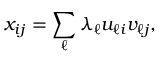Convert formula to latex. <formula><loc_0><loc_0><loc_500><loc_500>x _ { i j } = \sum _ { \ell } \lambda _ { \ell } u _ { \ell i } v _ { \ell j } ,</formula> 